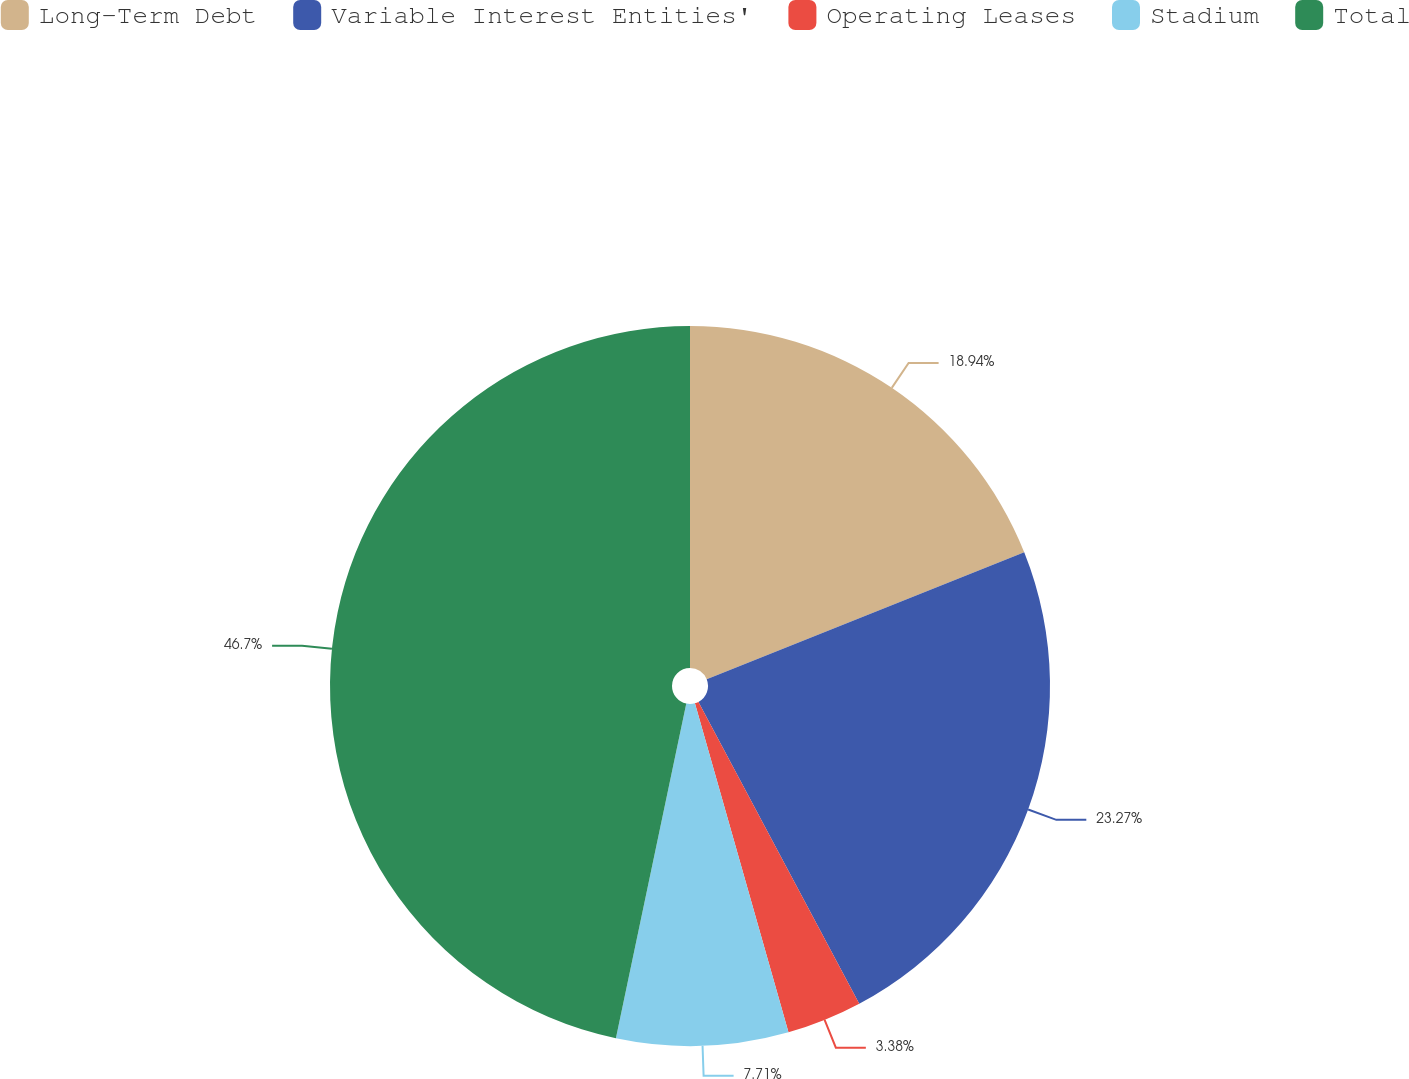<chart> <loc_0><loc_0><loc_500><loc_500><pie_chart><fcel>Long-Term Debt<fcel>Variable Interest Entities'<fcel>Operating Leases<fcel>Stadium<fcel>Total<nl><fcel>18.94%<fcel>23.27%<fcel>3.38%<fcel>7.71%<fcel>46.7%<nl></chart> 